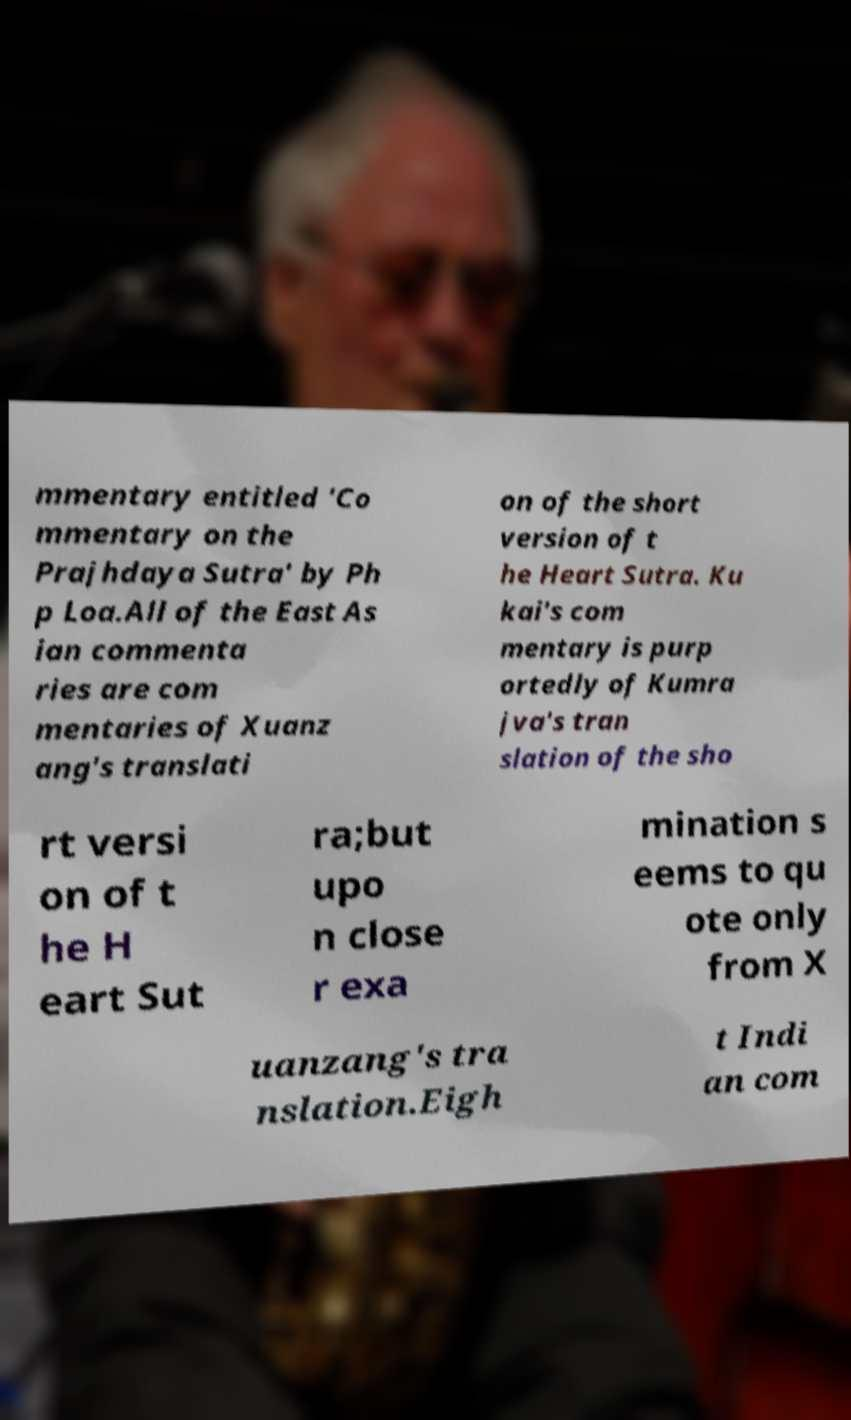Could you assist in decoding the text presented in this image and type it out clearly? mmentary entitled 'Co mmentary on the Prajhdaya Sutra' by Ph p Loa.All of the East As ian commenta ries are com mentaries of Xuanz ang's translati on of the short version of t he Heart Sutra. Ku kai's com mentary is purp ortedly of Kumra jva's tran slation of the sho rt versi on of t he H eart Sut ra;but upo n close r exa mination s eems to qu ote only from X uanzang's tra nslation.Eigh t Indi an com 